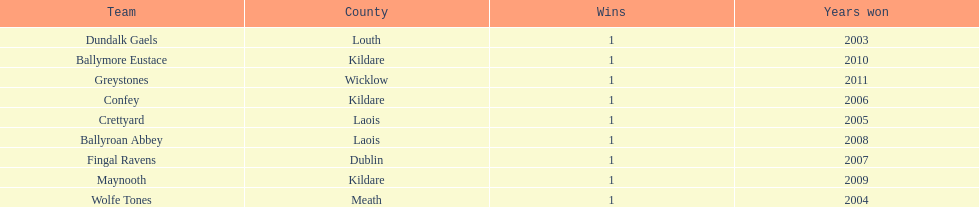Which team won previous to crettyard? Wolfe Tones. 